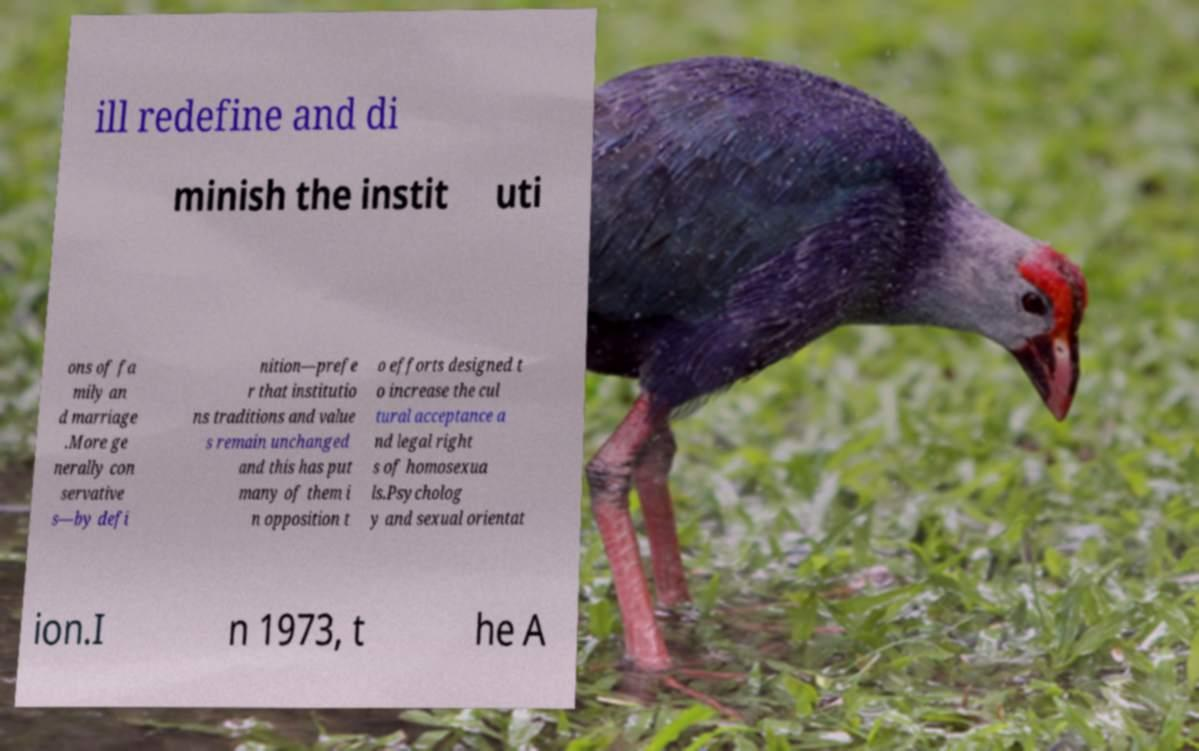Please read and relay the text visible in this image. What does it say? ill redefine and di minish the instit uti ons of fa mily an d marriage .More ge nerally con servative s—by defi nition—prefe r that institutio ns traditions and value s remain unchanged and this has put many of them i n opposition t o efforts designed t o increase the cul tural acceptance a nd legal right s of homosexua ls.Psycholog y and sexual orientat ion.I n 1973, t he A 